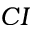<formula> <loc_0><loc_0><loc_500><loc_500>C I</formula> 